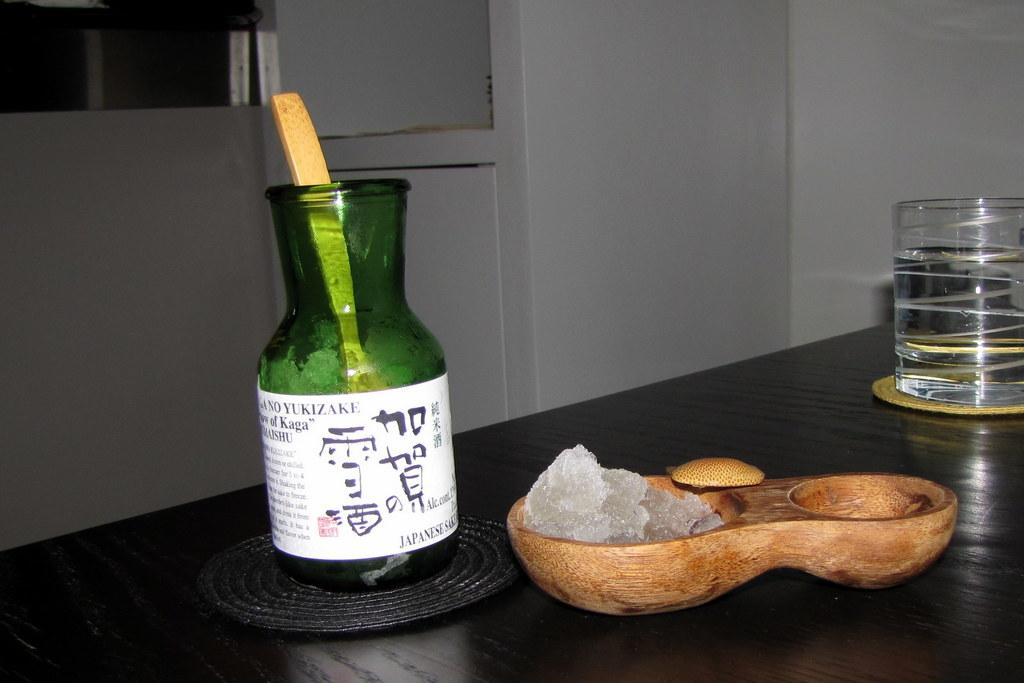What is the main setting of the picture? There is a room in the picture. What piece of furniture is present in the room? There is a table in the room. What items can be seen on the table? There is a bottle, a glass with liquid, and a bowl with ice on the table. What type of watch is the grandfather wearing in the image? There is no person, let alone a grandfather, present in the image. Therefore, there is no watch to be observed. 